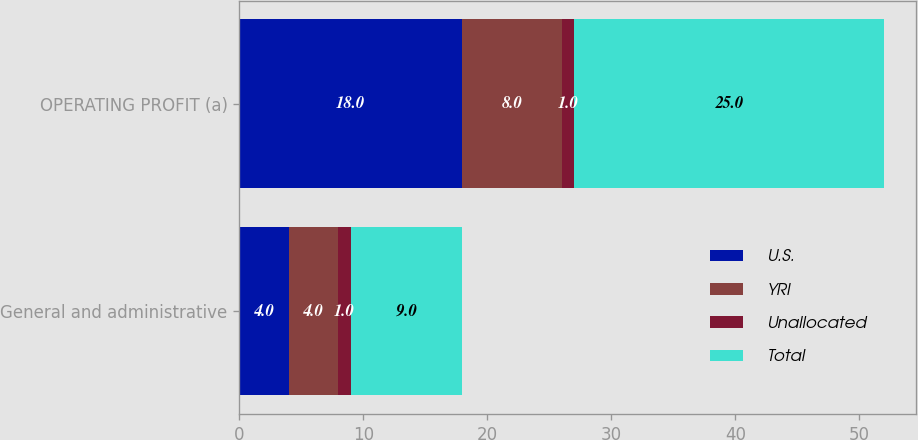<chart> <loc_0><loc_0><loc_500><loc_500><stacked_bar_chart><ecel><fcel>General and administrative<fcel>OPERATING PROFIT (a)<nl><fcel>U.S.<fcel>4<fcel>18<nl><fcel>YRI<fcel>4<fcel>8<nl><fcel>Unallocated<fcel>1<fcel>1<nl><fcel>Total<fcel>9<fcel>25<nl></chart> 